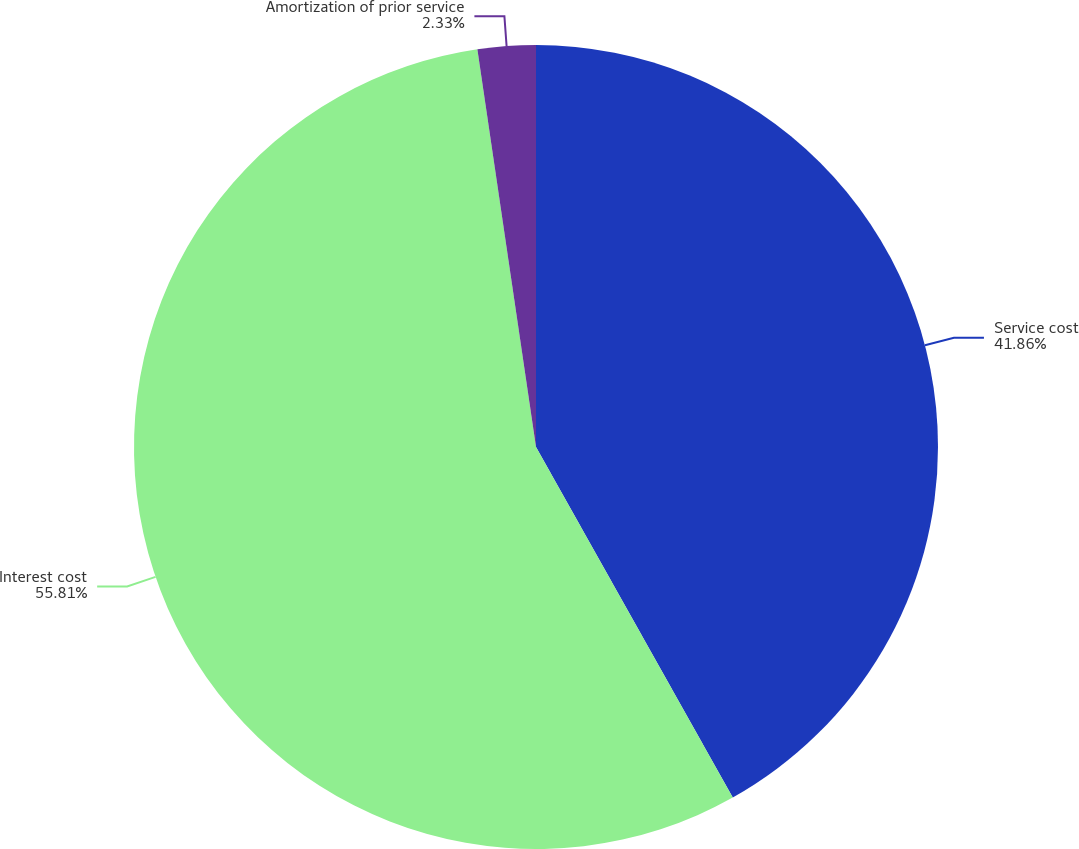Convert chart to OTSL. <chart><loc_0><loc_0><loc_500><loc_500><pie_chart><fcel>Service cost<fcel>Interest cost<fcel>Amortization of prior service<nl><fcel>41.86%<fcel>55.81%<fcel>2.33%<nl></chart> 